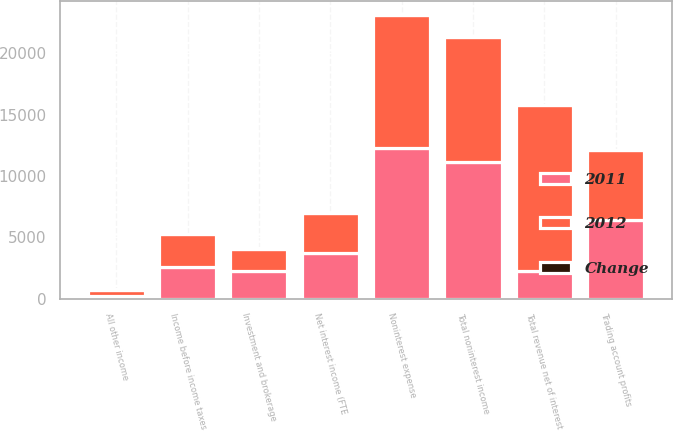<chart> <loc_0><loc_0><loc_500><loc_500><stacked_bar_chart><ecel><fcel>Net interest income (FTE<fcel>Investment and brokerage<fcel>Trading account profits<fcel>All other income<fcel>Total noninterest income<fcel>Total revenue net of interest<fcel>Noninterest expense<fcel>Income before income taxes<nl><fcel>2012<fcel>3310<fcel>1820<fcel>5706<fcel>469<fcel>10209<fcel>13519<fcel>10839<fcel>2677<nl><fcel>2011<fcel>3682<fcel>2249<fcel>6417<fcel>236<fcel>11116<fcel>2249<fcel>12244<fcel>2610<nl><fcel>Change<fcel>10<fcel>19<fcel>11<fcel>99<fcel>8<fcel>9<fcel>11<fcel>3<nl></chart> 